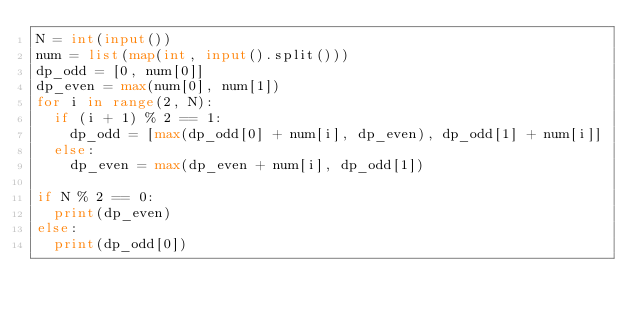Convert code to text. <code><loc_0><loc_0><loc_500><loc_500><_Python_>N = int(input())
num = list(map(int, input().split()))
dp_odd = [0, num[0]]
dp_even = max(num[0], num[1])
for i in range(2, N):
  if (i + 1) % 2 == 1:
    dp_odd = [max(dp_odd[0] + num[i], dp_even), dp_odd[1] + num[i]]
  else:
    dp_even = max(dp_even + num[i], dp_odd[1])

if N % 2 == 0:
  print(dp_even)
else:
  print(dp_odd[0])</code> 